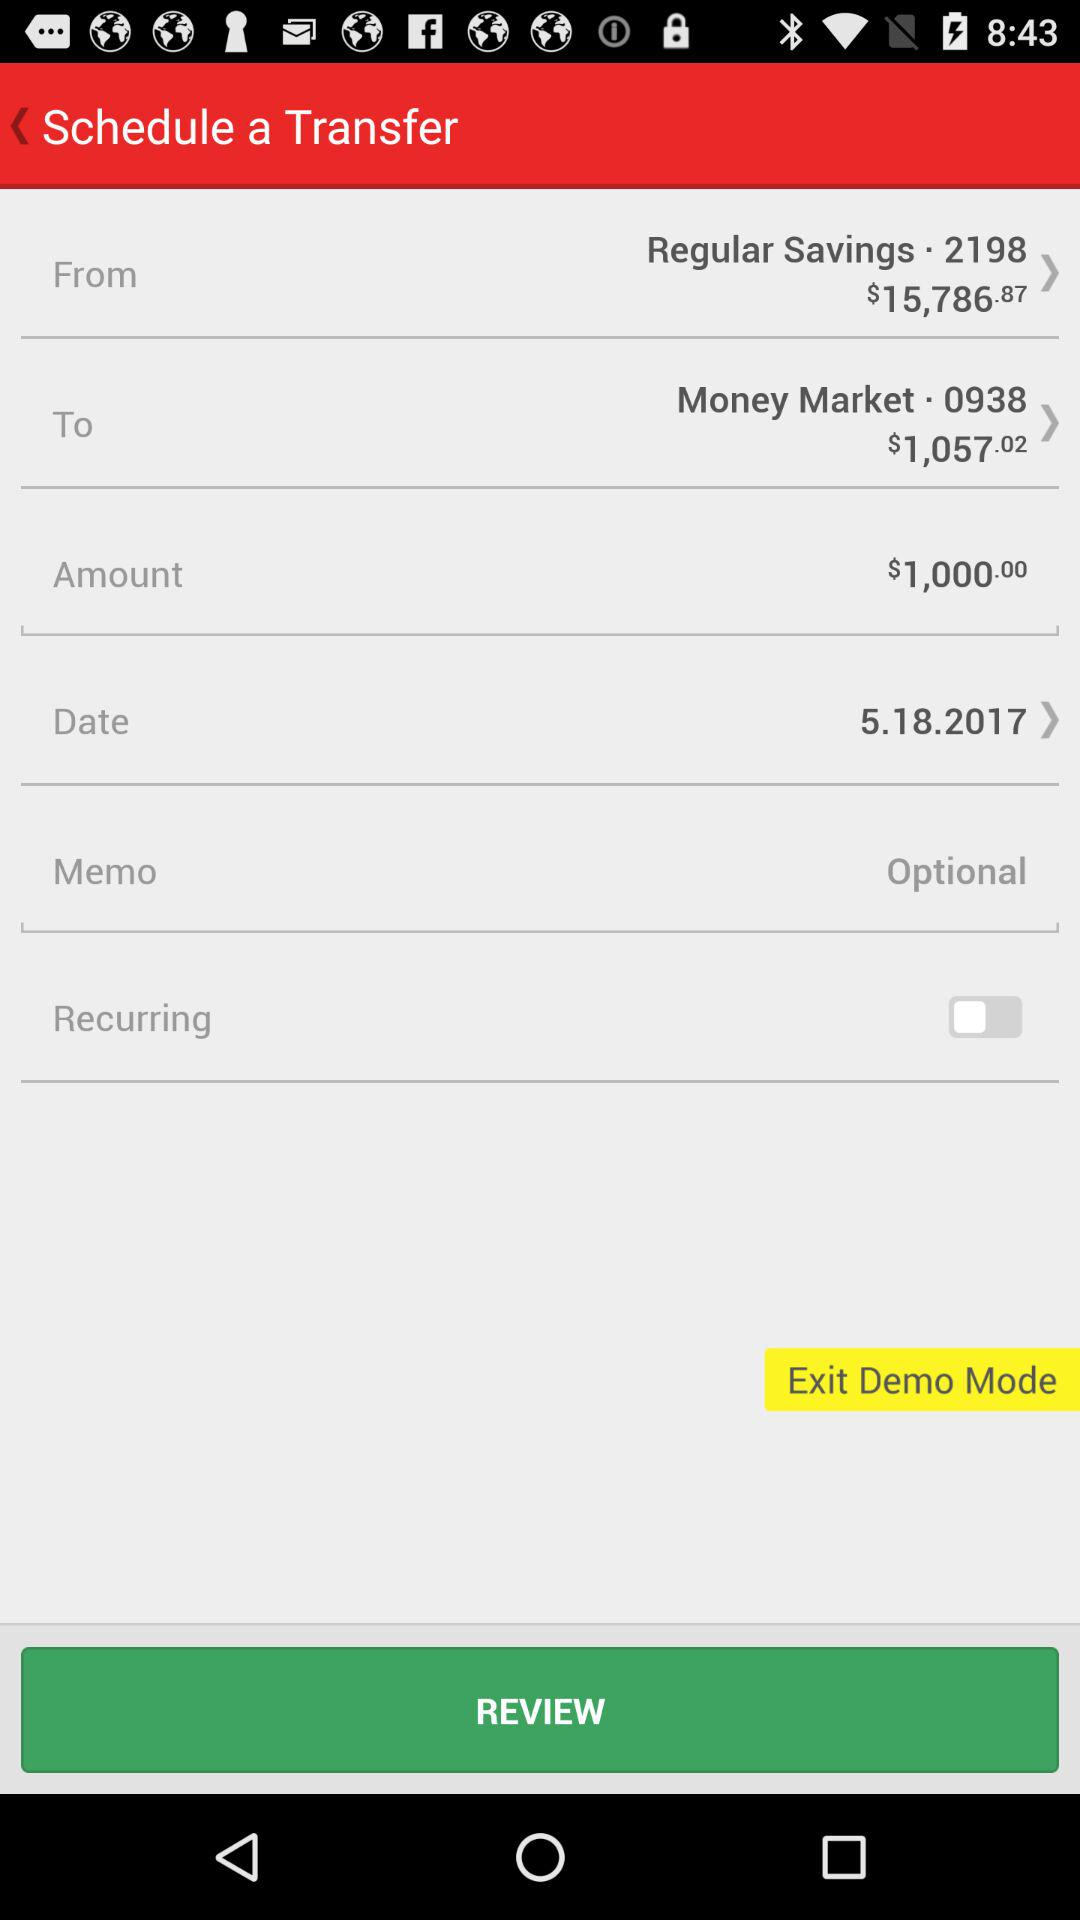How much more money is in the Regular Savings account than the Money Market account?
Answer the question using a single word or phrase. $14,729.85 